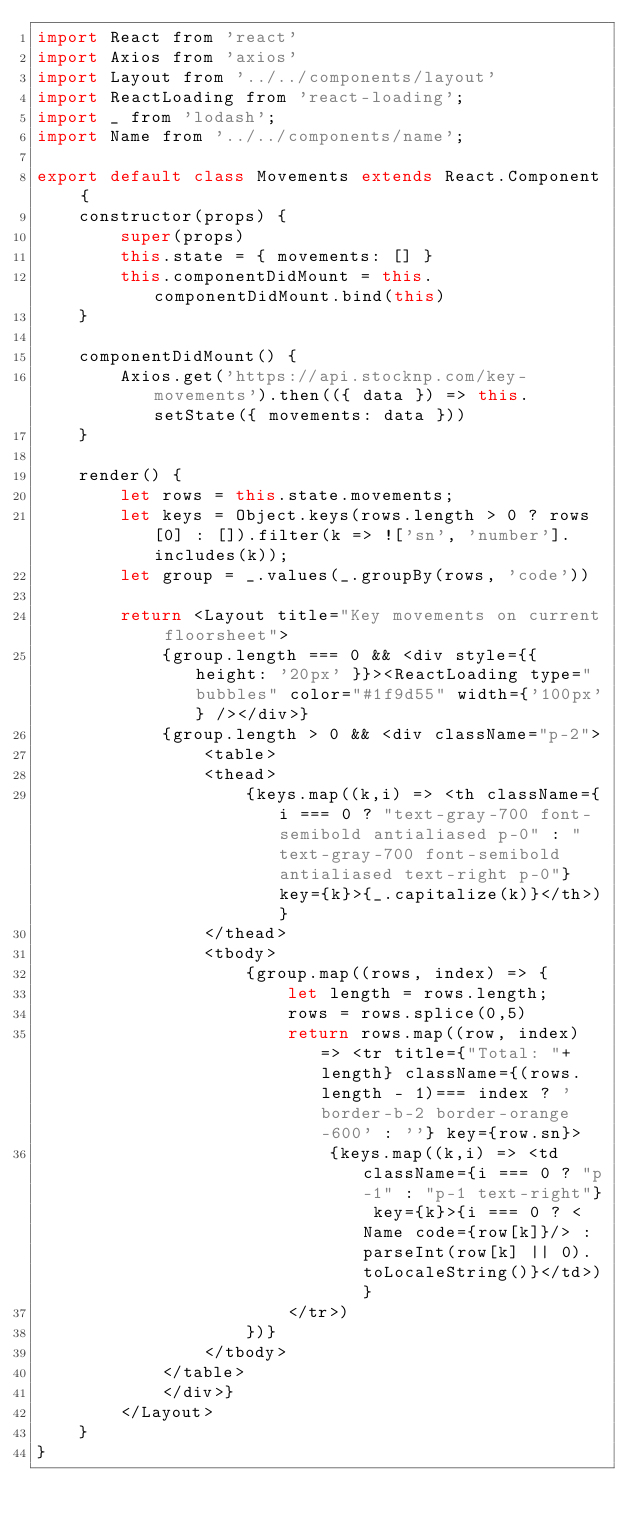<code> <loc_0><loc_0><loc_500><loc_500><_JavaScript_>import React from 'react'
import Axios from 'axios'
import Layout from '../../components/layout'
import ReactLoading from 'react-loading';
import _ from 'lodash';
import Name from '../../components/name';

export default class Movements extends React.Component {
    constructor(props) {
        super(props)
        this.state = { movements: [] }
        this.componentDidMount = this.componentDidMount.bind(this)
    }

    componentDidMount() {
        Axios.get('https://api.stocknp.com/key-movements').then(({ data }) => this.setState({ movements: data }))
    }

    render() {
        let rows = this.state.movements;
        let keys = Object.keys(rows.length > 0 ? rows[0] : []).filter(k => !['sn', 'number'].includes(k));
        let group = _.values(_.groupBy(rows, 'code'))

        return <Layout title="Key movements on current floorsheet">
            {group.length === 0 && <div style={{ height: '20px' }}><ReactLoading type="bubbles" color="#1f9d55" width={'100px'} /></div>}
            {group.length > 0 && <div className="p-2">
                <table>
                <thead>
                    {keys.map((k,i) => <th className={i === 0 ? "text-gray-700 font-semibold antialiased p-0" : "text-gray-700 font-semibold antialiased text-right p-0"} key={k}>{_.capitalize(k)}</th>)}
                </thead>
                <tbody>
                    {group.map((rows, index) => {
                        let length = rows.length;
                        rows = rows.splice(0,5)
                        return rows.map((row, index) => <tr title={"Total: "+length} className={(rows.length - 1)=== index ? 'border-b-2 border-orange-600' : ''} key={row.sn}>
                            {keys.map((k,i) => <td className={i === 0 ? "p-1" : "p-1 text-right"} key={k}>{i === 0 ? <Name code={row[k]}/> : parseInt(row[k] || 0).toLocaleString()}</td>)}
                        </tr>)
                    })}
                </tbody>
            </table>
            </div>}
        </Layout>
    }
}
</code> 